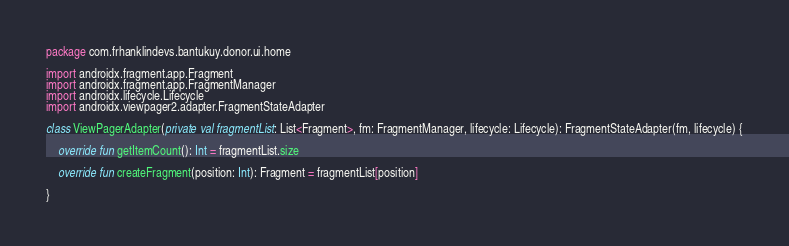Convert code to text. <code><loc_0><loc_0><loc_500><loc_500><_Kotlin_>package com.frhanklindevs.bantukuy.donor.ui.home

import androidx.fragment.app.Fragment
import androidx.fragment.app.FragmentManager
import androidx.lifecycle.Lifecycle
import androidx.viewpager2.adapter.FragmentStateAdapter

class ViewPagerAdapter(private val fragmentList: List<Fragment>, fm: FragmentManager, lifecycle: Lifecycle): FragmentStateAdapter(fm, lifecycle) {

    override fun getItemCount(): Int = fragmentList.size

    override fun createFragment(position: Int): Fragment = fragmentList[position]

}</code> 